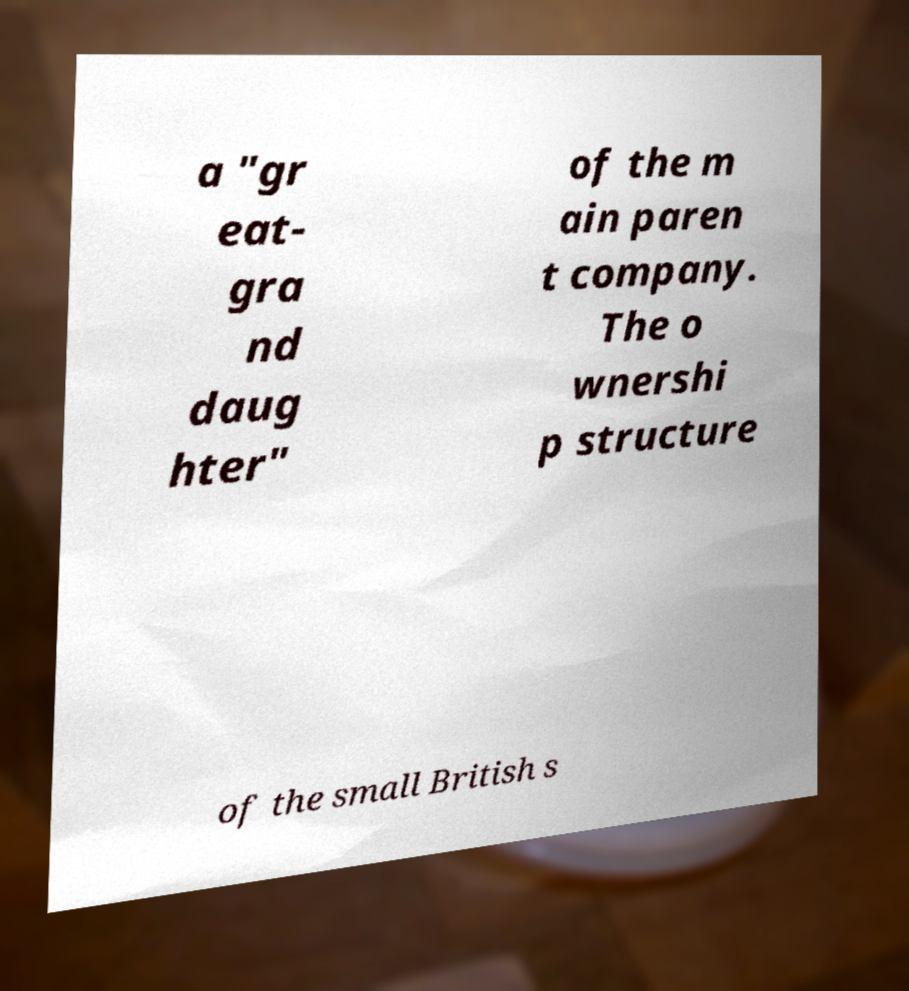What messages or text are displayed in this image? I need them in a readable, typed format. a "gr eat- gra nd daug hter" of the m ain paren t company. The o wnershi p structure of the small British s 